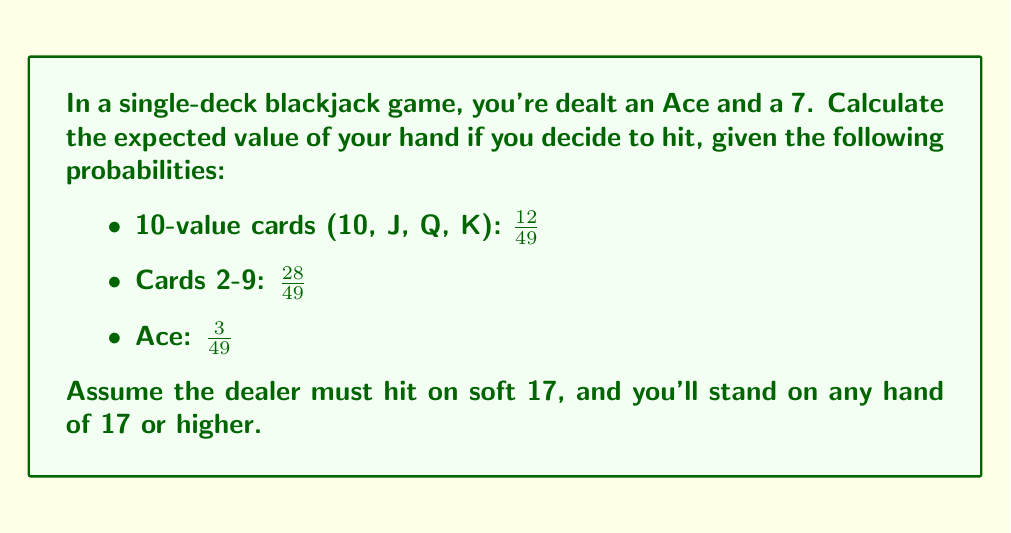Can you answer this question? Let's approach this step-by-step:

1) First, let's identify the possible outcomes:
   a) Drawing a 10-value card (18 total)
   b) Drawing a card 2-9
   c) Drawing an Ace (soft 19)

2) For outcome a (18 total):
   Probability: $P(a) = \frac{12}{49}$
   Value: Win (let's assign 1 unit)

3) For outcome b (drawing 2-9):
   We need to consider each card separately:
   - 2: $P(2) = \frac{4}{49}$, Value: 10 total, hit again (0)
   - 3: $P(3) = \frac{4}{49}$, Value: 11 total, hit again (0)
   - 4: $P(4) = \frac{4}{49}$, Value: 12 total, hit again (0)
   - 5: $P(5) = \frac{4}{49}$, Value: 13 total, hit again (0)
   - 6: $P(6) = \frac{4}{49}$, Value: 14 total, hit again (0)
   - 7: $P(7) = \frac{4}{49}$, Value: 15 total, hit again (0)
   - 8: $P(8) = \frac{4}{49}$, Value: 17 total, stand (0.5)
   - 9: $P(9) = \frac{4}{49}$, Value: 18 total, win (1)

4) For outcome c (soft 19):
   Probability: $P(c) = \frac{3}{49}$
   Value: Win (1 unit)

5) Now, let's calculate the expected value:

   $$ E = P(a) \cdot 1 + P(2-7) \cdot 0 + P(8) \cdot 0.5 + P(9) \cdot 1 + P(c) \cdot 1 $$

   $$ E = \frac{12}{49} \cdot 1 + \frac{24}{49} \cdot 0 + \frac{4}{49} \cdot 0.5 + \frac{4}{49} \cdot 1 + \frac{3}{49} \cdot 1 $$

   $$ E = \frac{12}{49} + \frac{2}{49} + \frac{4}{49} + \frac{3}{49} = \frac{21}{49} \approx 0.4286 $$
Answer: $\frac{21}{49}$ or approximately 0.4286 